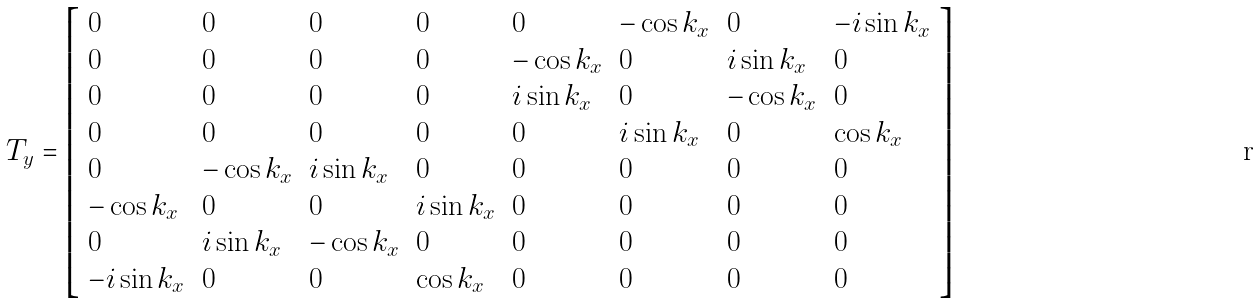<formula> <loc_0><loc_0><loc_500><loc_500>T _ { y } = \left [ \begin{array} { l l l l l l l l } 0 & 0 & 0 & 0 & 0 & - \cos k _ { x } & 0 & - i \sin k _ { x } \\ 0 & 0 & 0 & 0 & - \cos k _ { x } & 0 & i \sin k _ { x } & 0 \\ 0 & 0 & 0 & 0 & i \sin k _ { x } & 0 & - \cos k _ { x } & 0 \\ 0 & 0 & 0 & 0 & 0 & i \sin k _ { x } & 0 & \cos k _ { x } \\ 0 & - \cos k _ { x } & i \sin k _ { x } & 0 & 0 & 0 & 0 & 0 \\ - \cos k _ { x } & 0 & 0 & i \sin k _ { x } & 0 & 0 & 0 & 0 \\ 0 & i \sin k _ { x } & - \cos k _ { x } & 0 & 0 & 0 & 0 & 0 \\ - i \sin k _ { x } & 0 & 0 & \cos k _ { x } & 0 & 0 & 0 & 0 \end{array} \right ]</formula> 